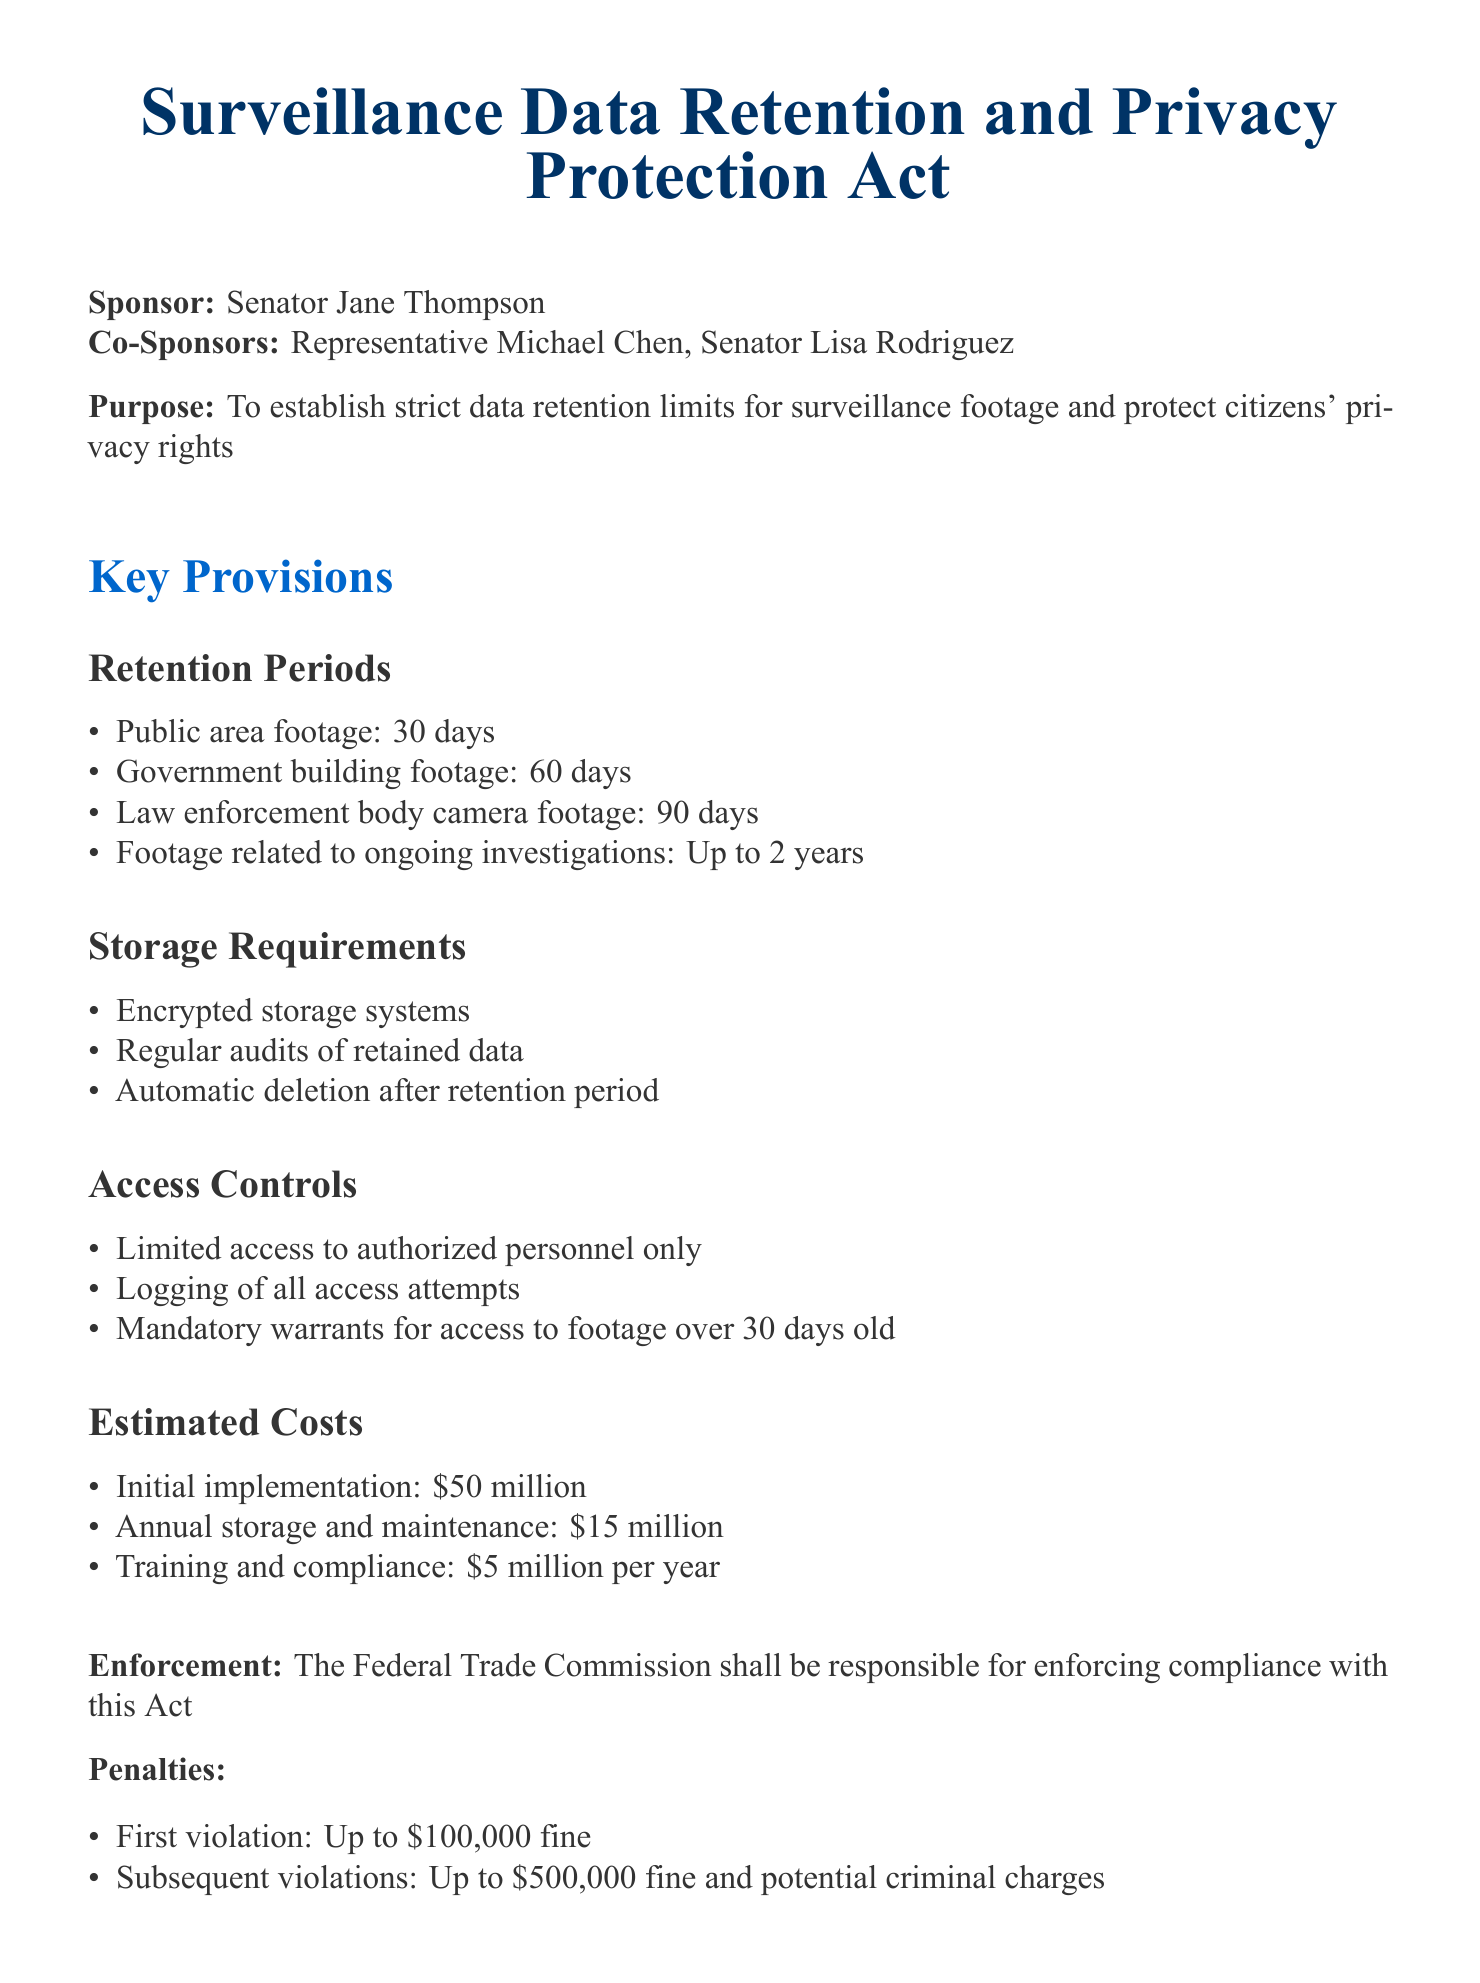What is the retention period for public area footage? The retention period for public area footage is specifically mentioned in the document as being 30 days.
Answer: 30 days How long must law enforcement body camera footage be retained? The document states that law enforcement body camera footage must be retained for 90 days.
Answer: 90 days What is the estimated initial implementation cost? The document provides the initial implementation cost as $50 million.
Answer: $50 million Who is responsible for enforcing compliance with this Act? The document specifies that the Federal Trade Commission is responsible for enforcement.
Answer: Federal Trade Commission What is the penalty for a first violation? The document indicates the penalty for a first violation is up to a $100,000 fine.
Answer: Up to $100,000 fine For how long can footage related to ongoing investigations be retained? According to the document, footage related to ongoing investigations can be retained for up to 2 years.
Answer: Up to 2 years What type of storage systems are required? The document mandates the use of encrypted storage systems.
Answer: Encrypted storage systems How often should audits of retained data occur? The document states there should be regular audits of retained data, though it does not specify the frequency.
Answer: Regular audits What date does the Act become effective? The effective date for the Act is outlined clearly as January 1, 2024.
Answer: January 1, 2024 